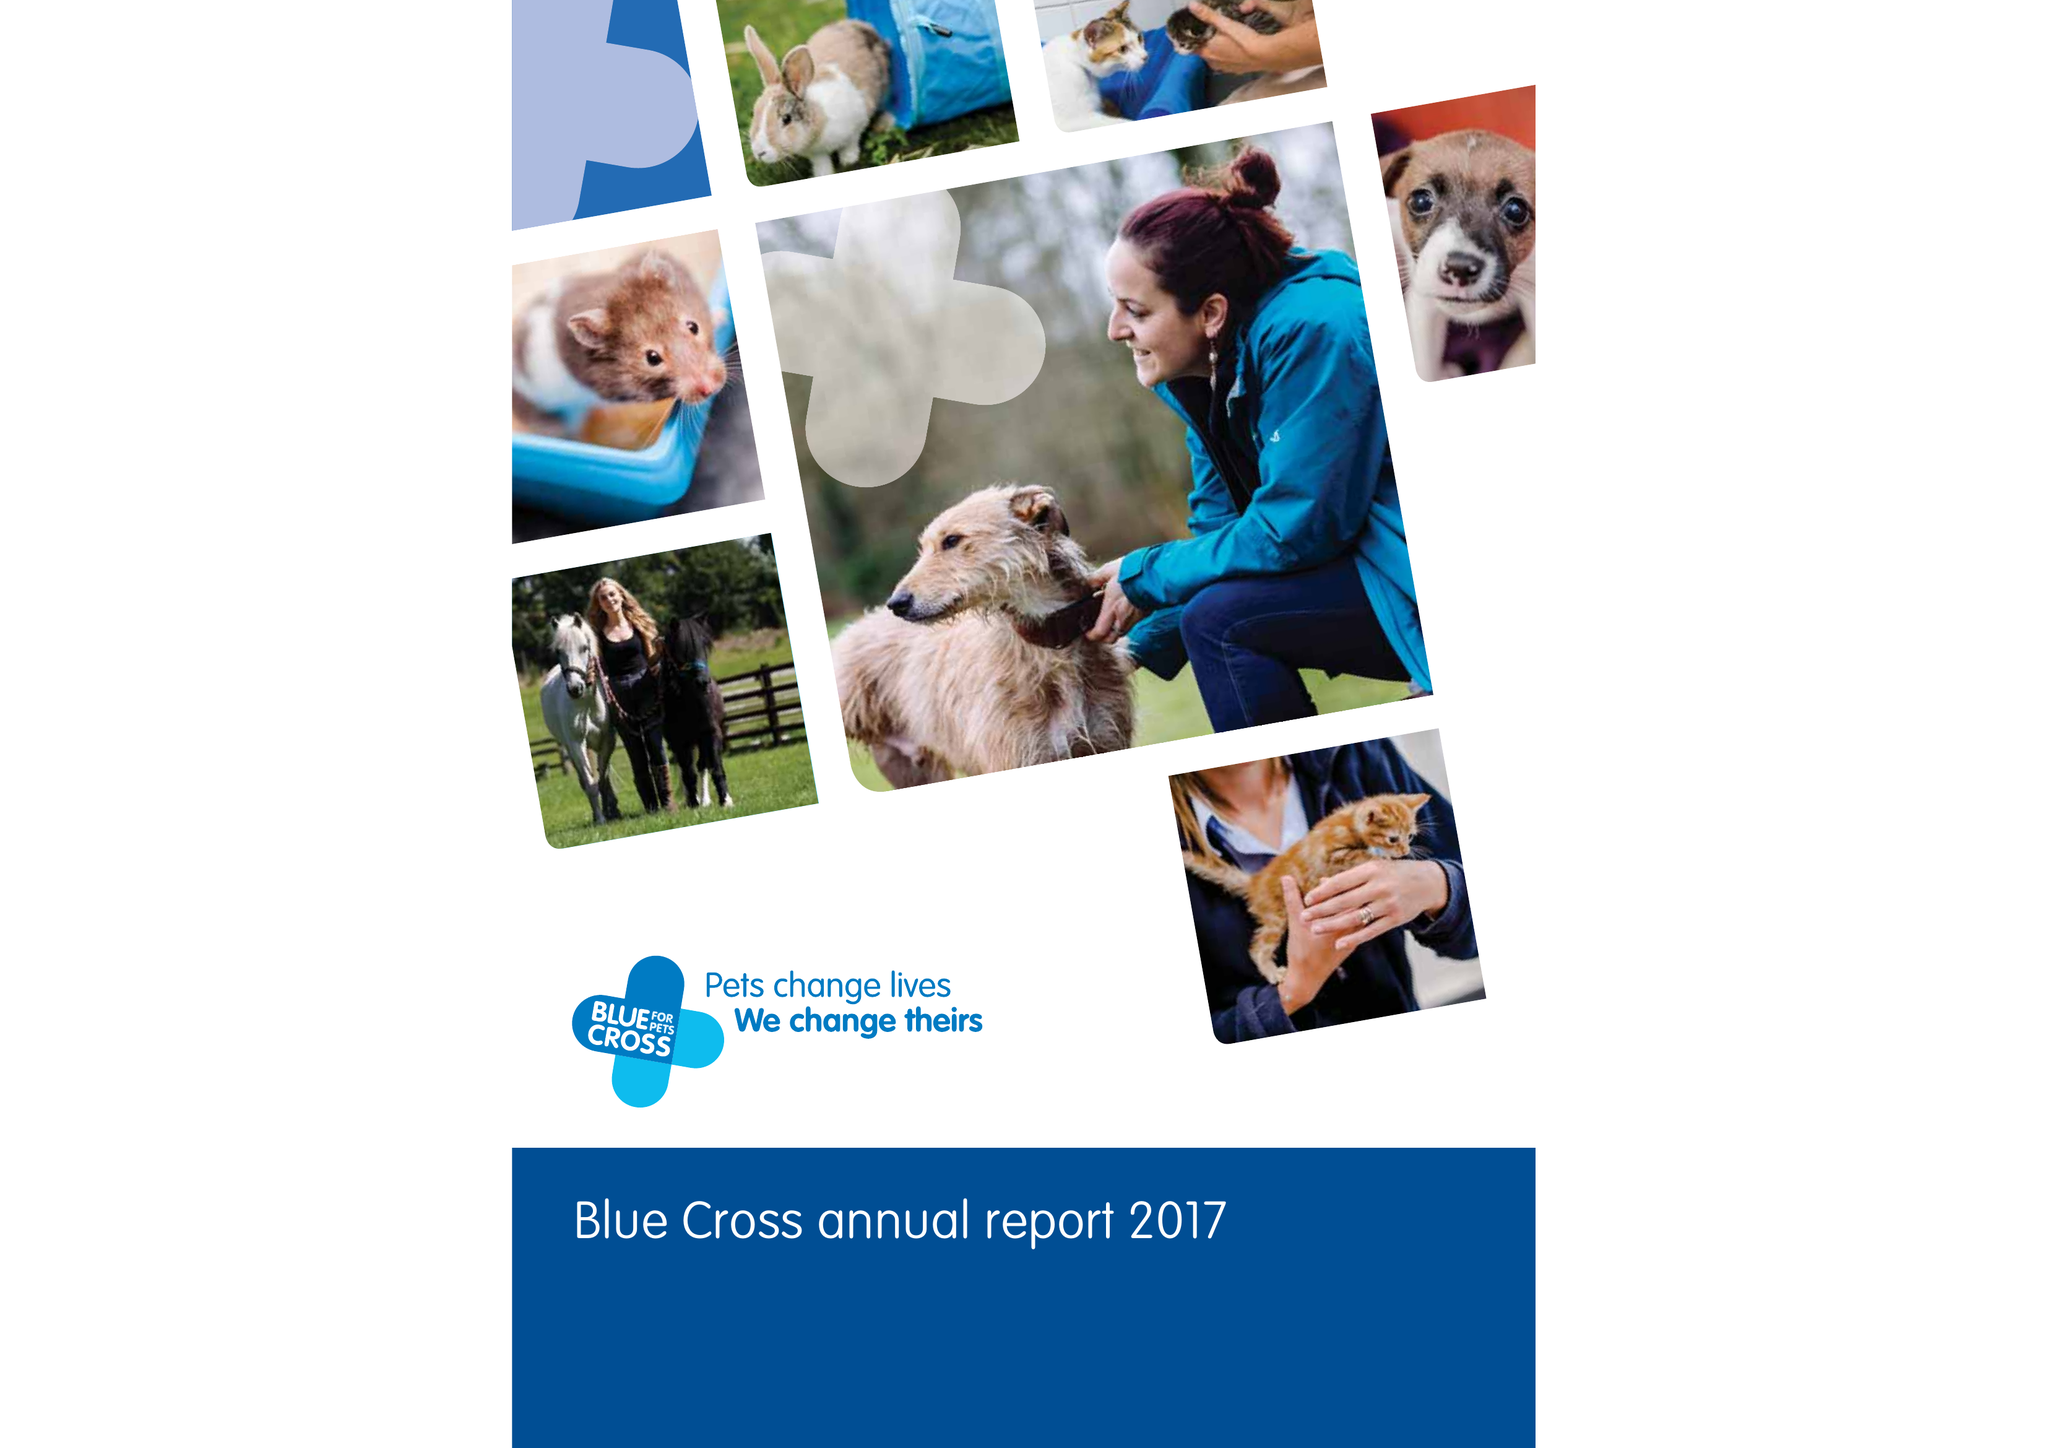What is the value for the address__street_line?
Answer the question using a single word or phrase. SHILTON ROAD 